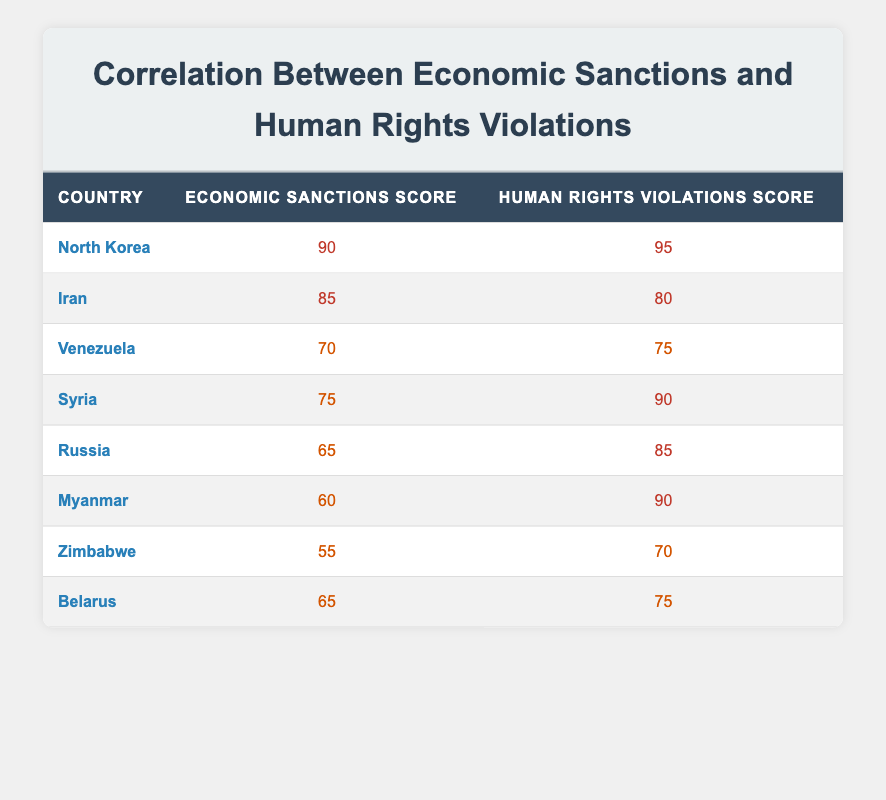What is the economic sanctions score of North Korea? North Korea's economic sanctions score is directly listed in the table under its name, which shows a score of 90.
Answer: 90 What is the human rights violations score for Belarus? The table indicates that Belarus has a human rights violations score of 75 when looking under its name.
Answer: 75 Which country has the highest economic sanctions score? By examining the economic sanctions scores listed in the table, North Korea has the highest score of 90.
Answer: North Korea What is the average economic sanctions score of the countries listed? To find the average, sum all economic sanctions scores: (90 + 85 + 70 + 75 + 65 + 60 + 55 + 65) = 675. There are 8 countries, so the average is 675/8 = 84.375.
Answer: 84.375 Is it true that Iran has a higher human rights violations score than Venezuela? Comparing the human rights violations scores, Iran has 80 and Venezuela has 75, indicating that Iran's score is indeed higher.
Answer: Yes Which countries have economic sanctions scores of at least 70 and human rights violations scores of at least 80? Looking at both scores, North Korea (90, 95) and Syria (75, 90) meet this criterion since North Korea's scores are above both thresholds and Syria's human rights score exceeds 80.
Answer: North Korea, Syria What is the difference between the economic sanctions score of Myanmar and the human rights violations score of Syria? Myanmar's economic sanctions score is 60, and Syria's human rights violations score is 90. The difference is 90 - 60 = 30.
Answer: 30 Which country's human rights violations score is closest to its economic sanctions score? By examining the scores, Iran has a 5-point difference (85 for economic sanctions and 80 for human rights violations), which is the smallest difference among the listed countries.
Answer: Iran What is the median economic sanctions score for the listed countries? To find the median, order the economic sanctions scores: 55, 60, 65, 65, 70, 75, 85, 90. The median score is the average of the two middle numbers: (65 + 70)/2 = 67.5.
Answer: 67.5 